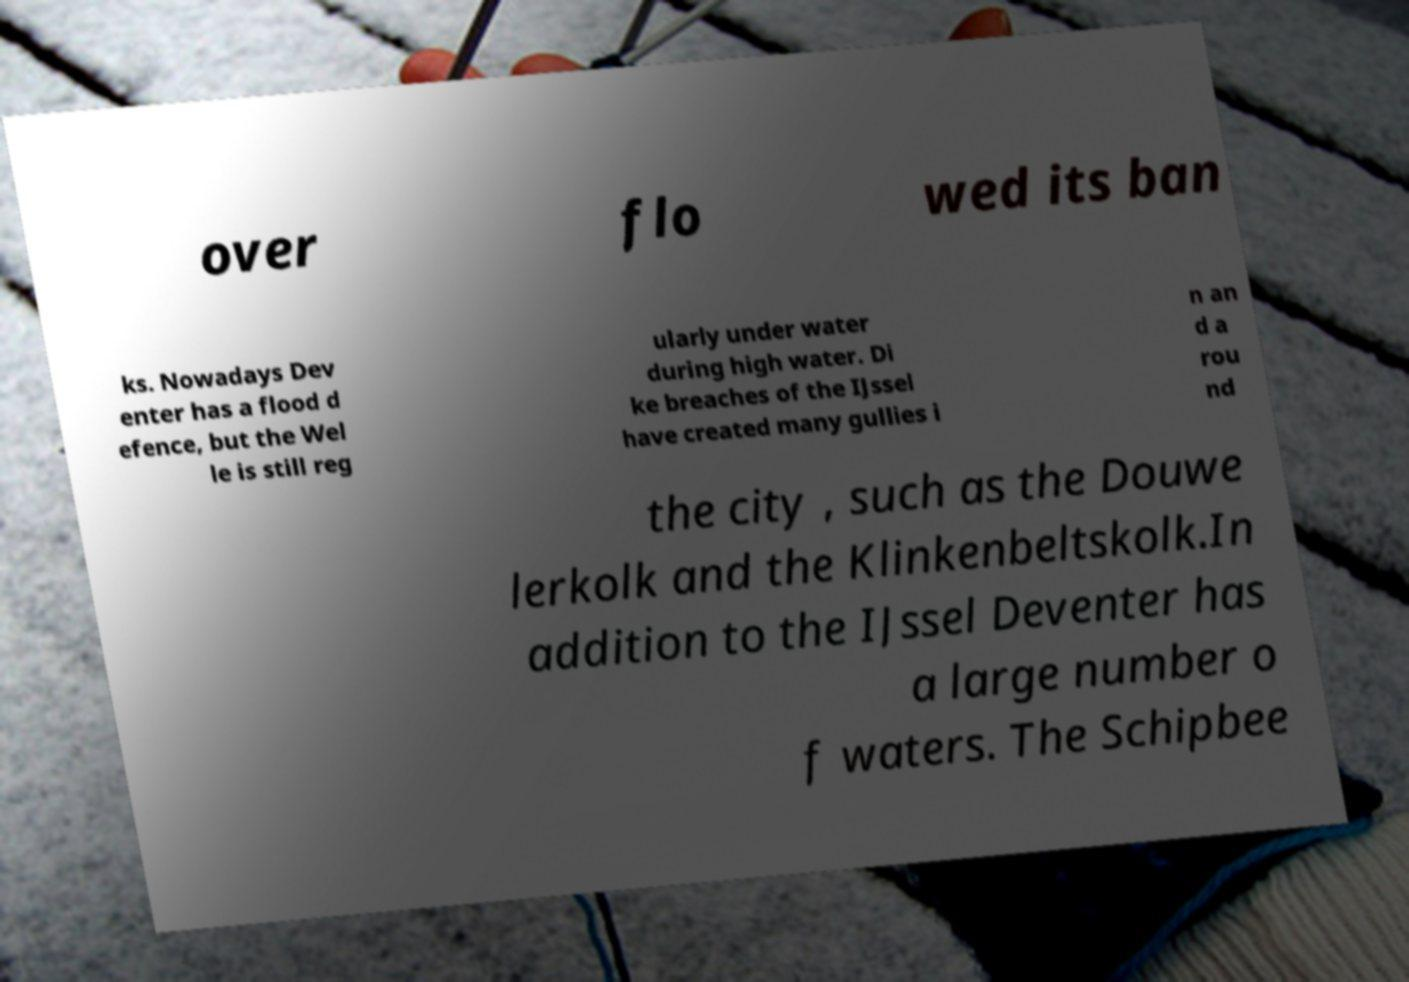I need the written content from this picture converted into text. Can you do that? over flo wed its ban ks. Nowadays Dev enter has a flood d efence, but the Wel le is still reg ularly under water during high water. Di ke breaches of the IJssel have created many gullies i n an d a rou nd the city , such as the Douwe lerkolk and the Klinkenbeltskolk.In addition to the IJssel Deventer has a large number o f waters. The Schipbee 